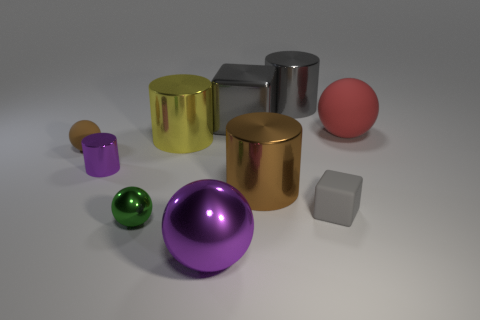What is the shape of the big matte thing?
Your answer should be very brief. Sphere. Do the purple metallic object left of the small green metal object and the brown matte object have the same shape?
Keep it short and to the point. No. Is the number of big metal spheres behind the big brown cylinder greater than the number of large shiny cubes that are to the left of the big yellow cylinder?
Provide a short and direct response. No. How many other objects are the same size as the shiny block?
Offer a terse response. 5. Is the shape of the tiny gray object the same as the brown thing on the right side of the small brown rubber ball?
Provide a short and direct response. No. How many matte objects are big red cylinders or large gray cylinders?
Provide a succinct answer. 0. Is there a metal object that has the same color as the tiny matte block?
Keep it short and to the point. Yes. Are any large brown metallic cubes visible?
Provide a short and direct response. No. Does the tiny brown thing have the same shape as the small gray object?
Your answer should be compact. No. How many tiny things are either green metallic spheres or brown metal cylinders?
Offer a terse response. 1. 